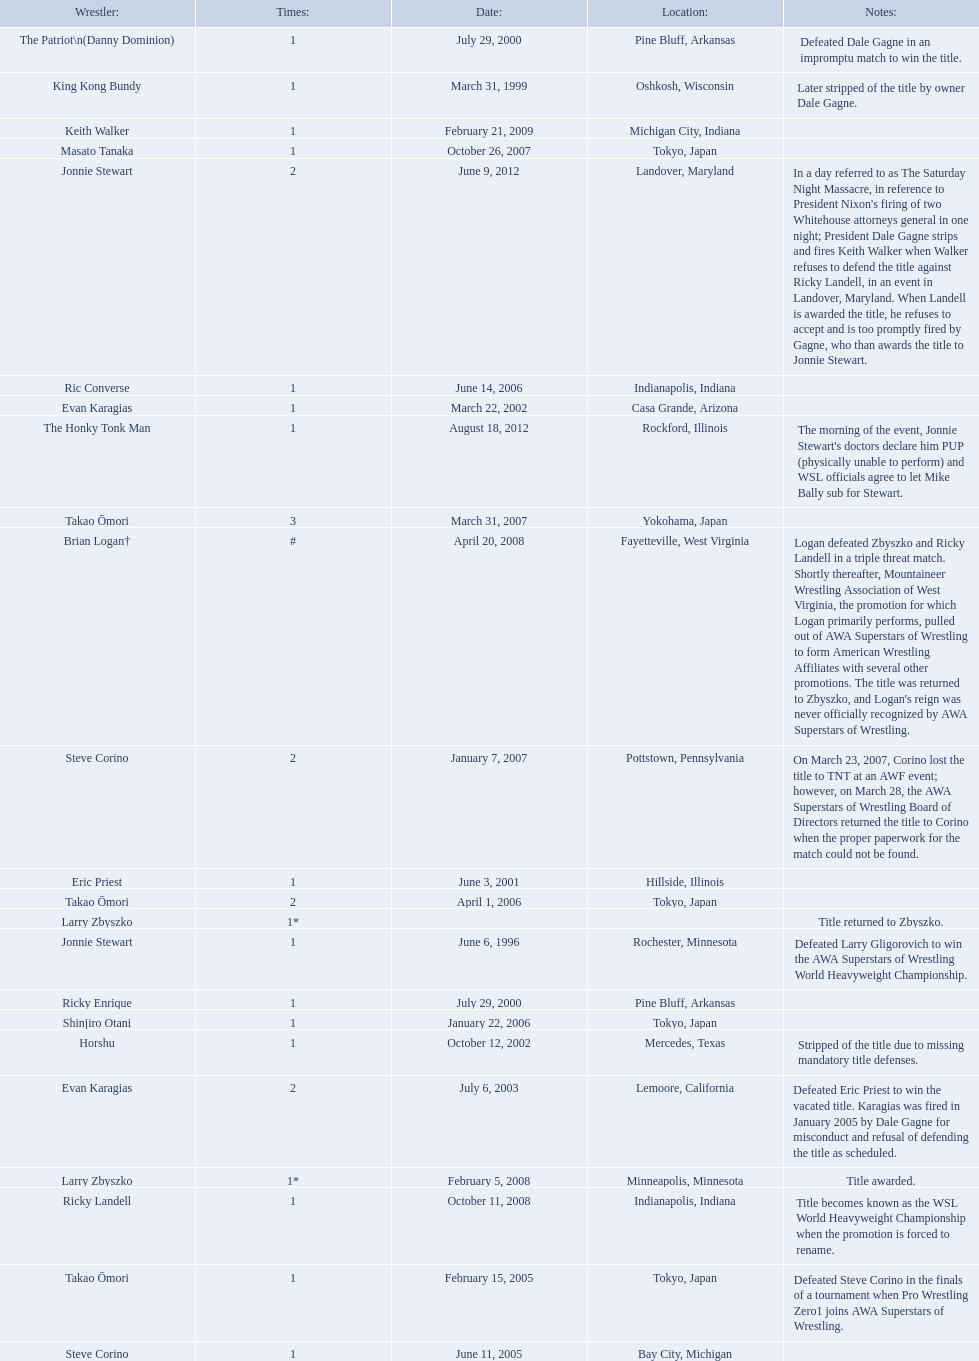Who are the wrestlers? Jonnie Stewart, Rochester, Minnesota, King Kong Bundy, Oshkosh, Wisconsin, The Patriot\n(Danny Dominion), Pine Bluff, Arkansas, Ricky Enrique, Pine Bluff, Arkansas, Eric Priest, Hillside, Illinois, Evan Karagias, Casa Grande, Arizona, Horshu, Mercedes, Texas, Evan Karagias, Lemoore, California, Takao Ōmori, Tokyo, Japan, Steve Corino, Bay City, Michigan, Shinjiro Otani, Tokyo, Japan, Takao Ōmori, Tokyo, Japan, Ric Converse, Indianapolis, Indiana, Steve Corino, Pottstown, Pennsylvania, Takao Ōmori, Yokohama, Japan, Masato Tanaka, Tokyo, Japan, Larry Zbyszko, Minneapolis, Minnesota, Brian Logan†, Fayetteville, West Virginia, Larry Zbyszko, , Ricky Landell, Indianapolis, Indiana, Keith Walker, Michigan City, Indiana, Jonnie Stewart, Landover, Maryland, The Honky Tonk Man, Rockford, Illinois. Who was from texas? Horshu, Mercedes, Texas. Who is he? Horshu. 